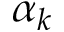<formula> <loc_0><loc_0><loc_500><loc_500>\alpha _ { k }</formula> 